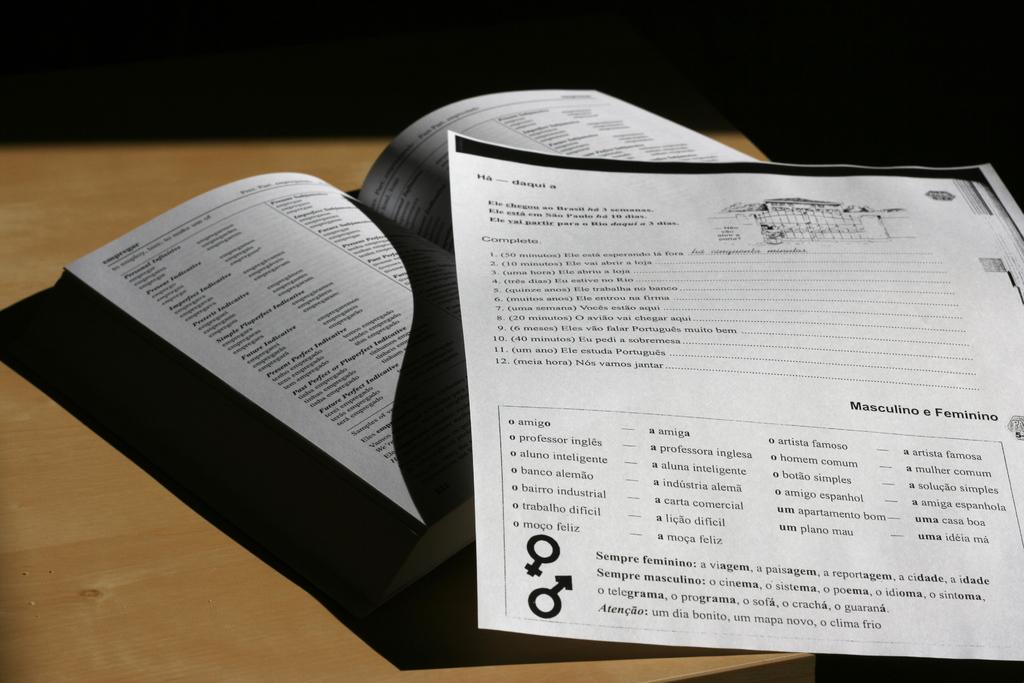What is the first word written in the box on the bottom of the page?
Offer a terse response. Amigo. What is the heading of the 2nd section?
Provide a short and direct response. Masculino e feminino. 